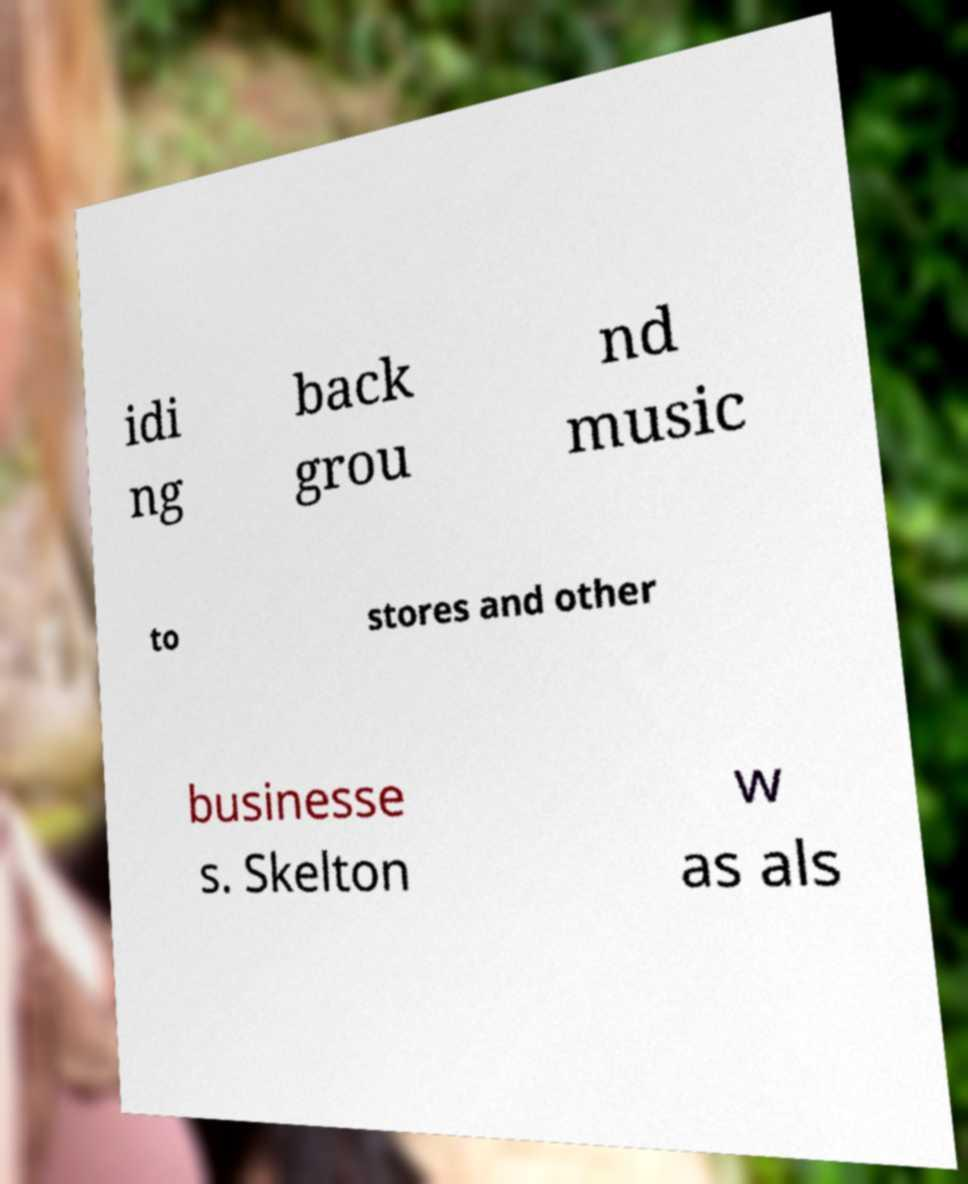Please read and relay the text visible in this image. What does it say? idi ng back grou nd music to stores and other businesse s. Skelton w as als 